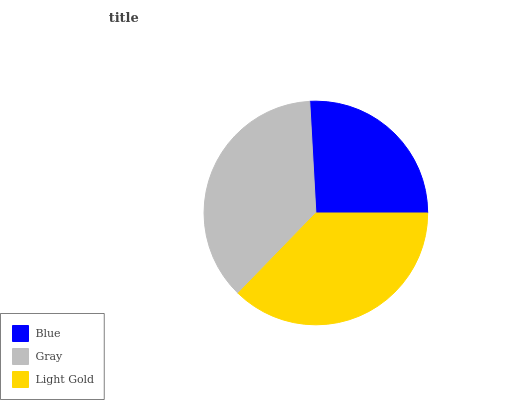Is Blue the minimum?
Answer yes or no. Yes. Is Light Gold the maximum?
Answer yes or no. Yes. Is Gray the minimum?
Answer yes or no. No. Is Gray the maximum?
Answer yes or no. No. Is Gray greater than Blue?
Answer yes or no. Yes. Is Blue less than Gray?
Answer yes or no. Yes. Is Blue greater than Gray?
Answer yes or no. No. Is Gray less than Blue?
Answer yes or no. No. Is Gray the high median?
Answer yes or no. Yes. Is Gray the low median?
Answer yes or no. Yes. Is Light Gold the high median?
Answer yes or no. No. Is Blue the low median?
Answer yes or no. No. 